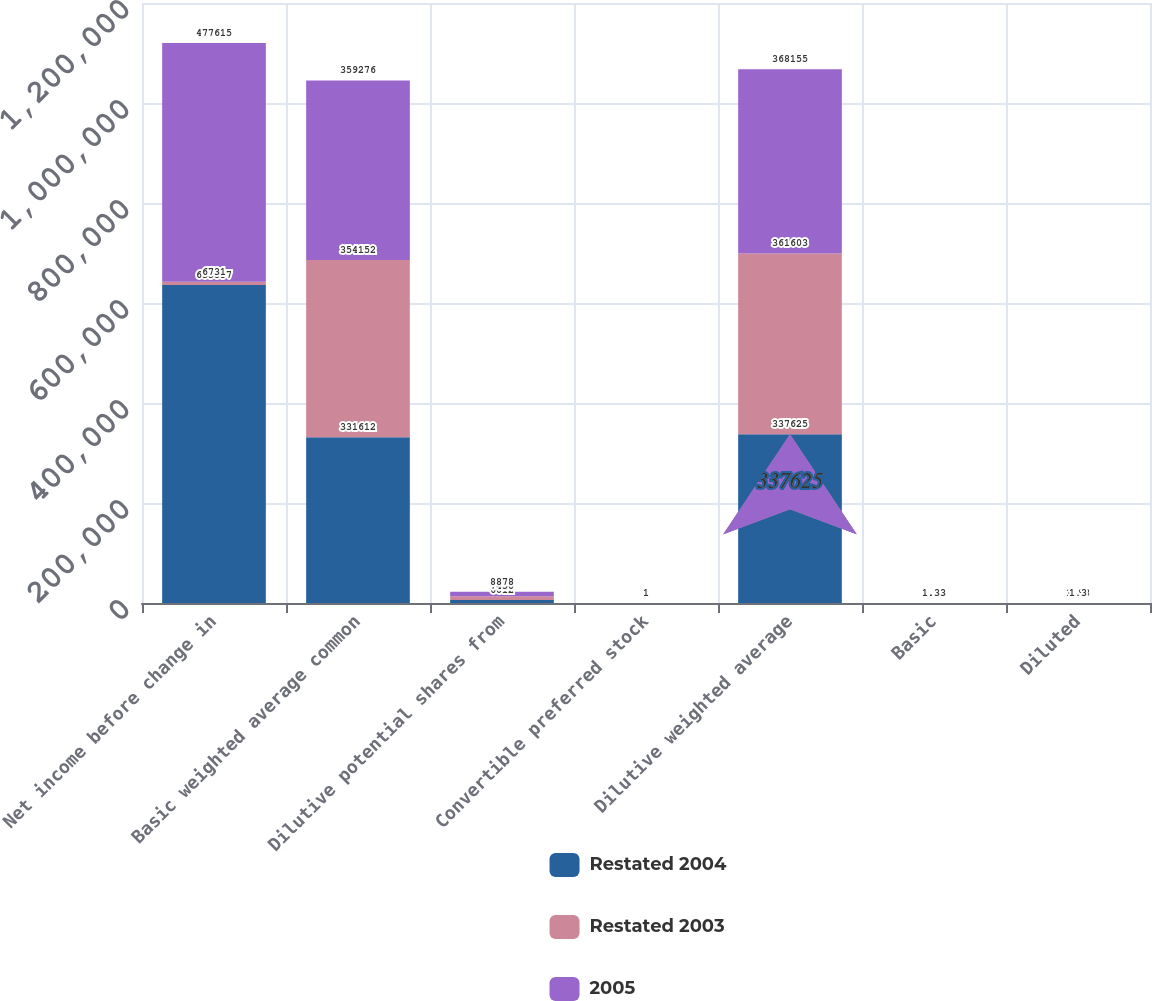Convert chart to OTSL. <chart><loc_0><loc_0><loc_500><loc_500><stacked_bar_chart><ecel><fcel>Net income before change in<fcel>Basic weighted average common<fcel>Dilutive potential shares from<fcel>Convertible preferred stock<fcel>Dilutive weighted average<fcel>Basic<fcel>Diluted<nl><fcel>Restated 2004<fcel>635857<fcel>331612<fcel>6012<fcel>1<fcel>337625<fcel>1.92<fcel>1.88<nl><fcel>Restated 2003<fcel>6731<fcel>354152<fcel>7450<fcel>1<fcel>361603<fcel>2.02<fcel>1.98<nl><fcel>2005<fcel>477615<fcel>359276<fcel>8878<fcel>1<fcel>368155<fcel>1.33<fcel>1.3<nl></chart> 